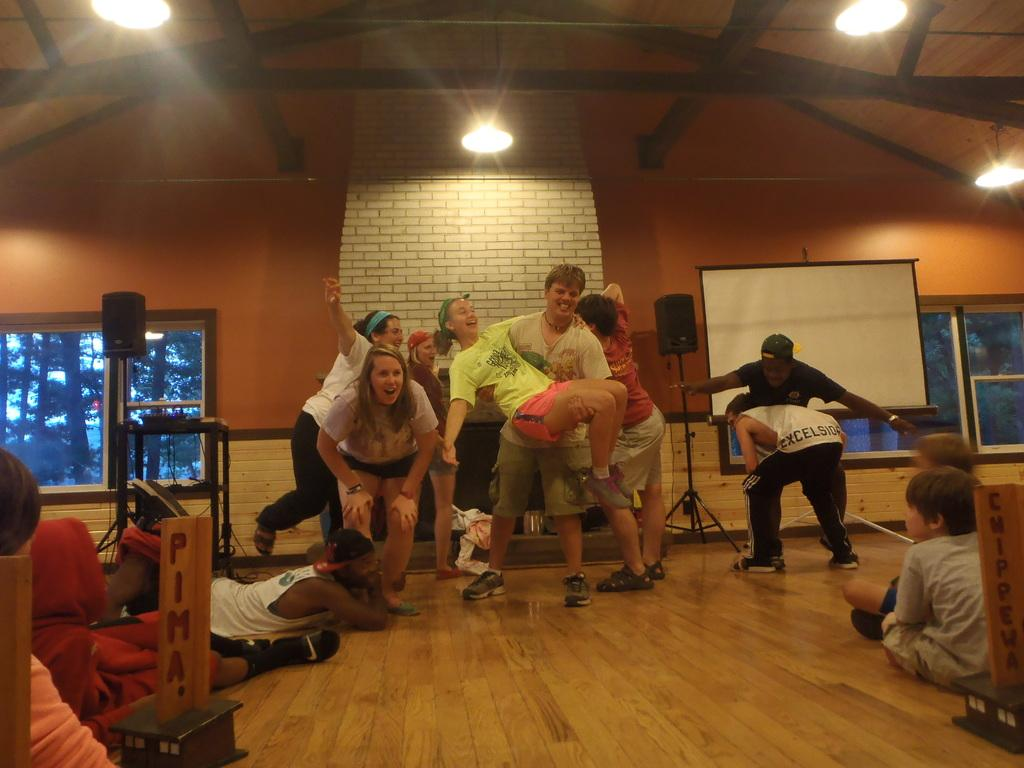<image>
Render a clear and concise summary of the photo. People acting out a scenario and a wood box to the left with PIMA engraved on it. 